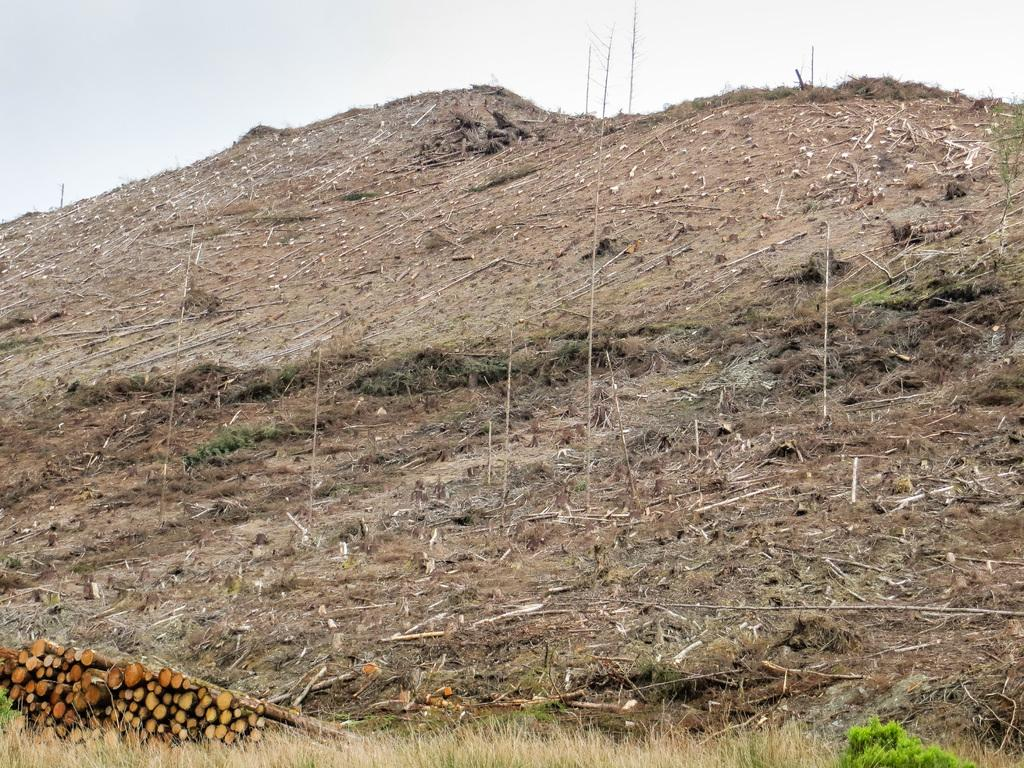What type of material is the main subject of the image made of? The main subject of the image is made of wooden logs. What can be seen growing in the image? There is grass and plants visible in the image. What is visible in the background of the image? The sky is visible in the image. What type of knot is being used to secure the chess pieces in the image? There is no knot or chess pieces present in the image; it features wooden logs, grass, plants, and the sky. 